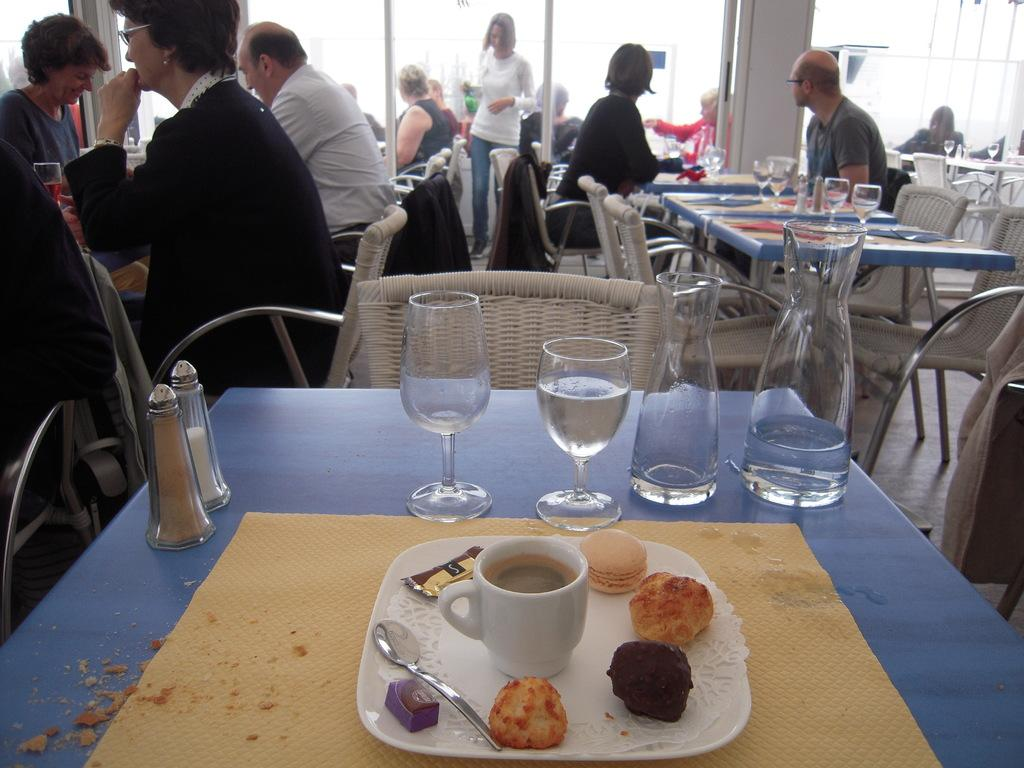What is the main piece of furniture in the image? There is a table in the image. What items are placed on the table? Glasses, a bottle, a plate, a cup, spoons, and biscuits are placed on the table. Can you describe the people in the background of the image? There are people sitting in the background of the image. What type of wren can be seen perched on the cup in the image? There is no wren present in the image; it features a table with various items and people sitting in the background. What color is the dress worn by the person sitting at the table? There is no person sitting at the table in the image, only people sitting in the background. Is there a kettle visible on the table in the image? No, there is no kettle present in the image. 